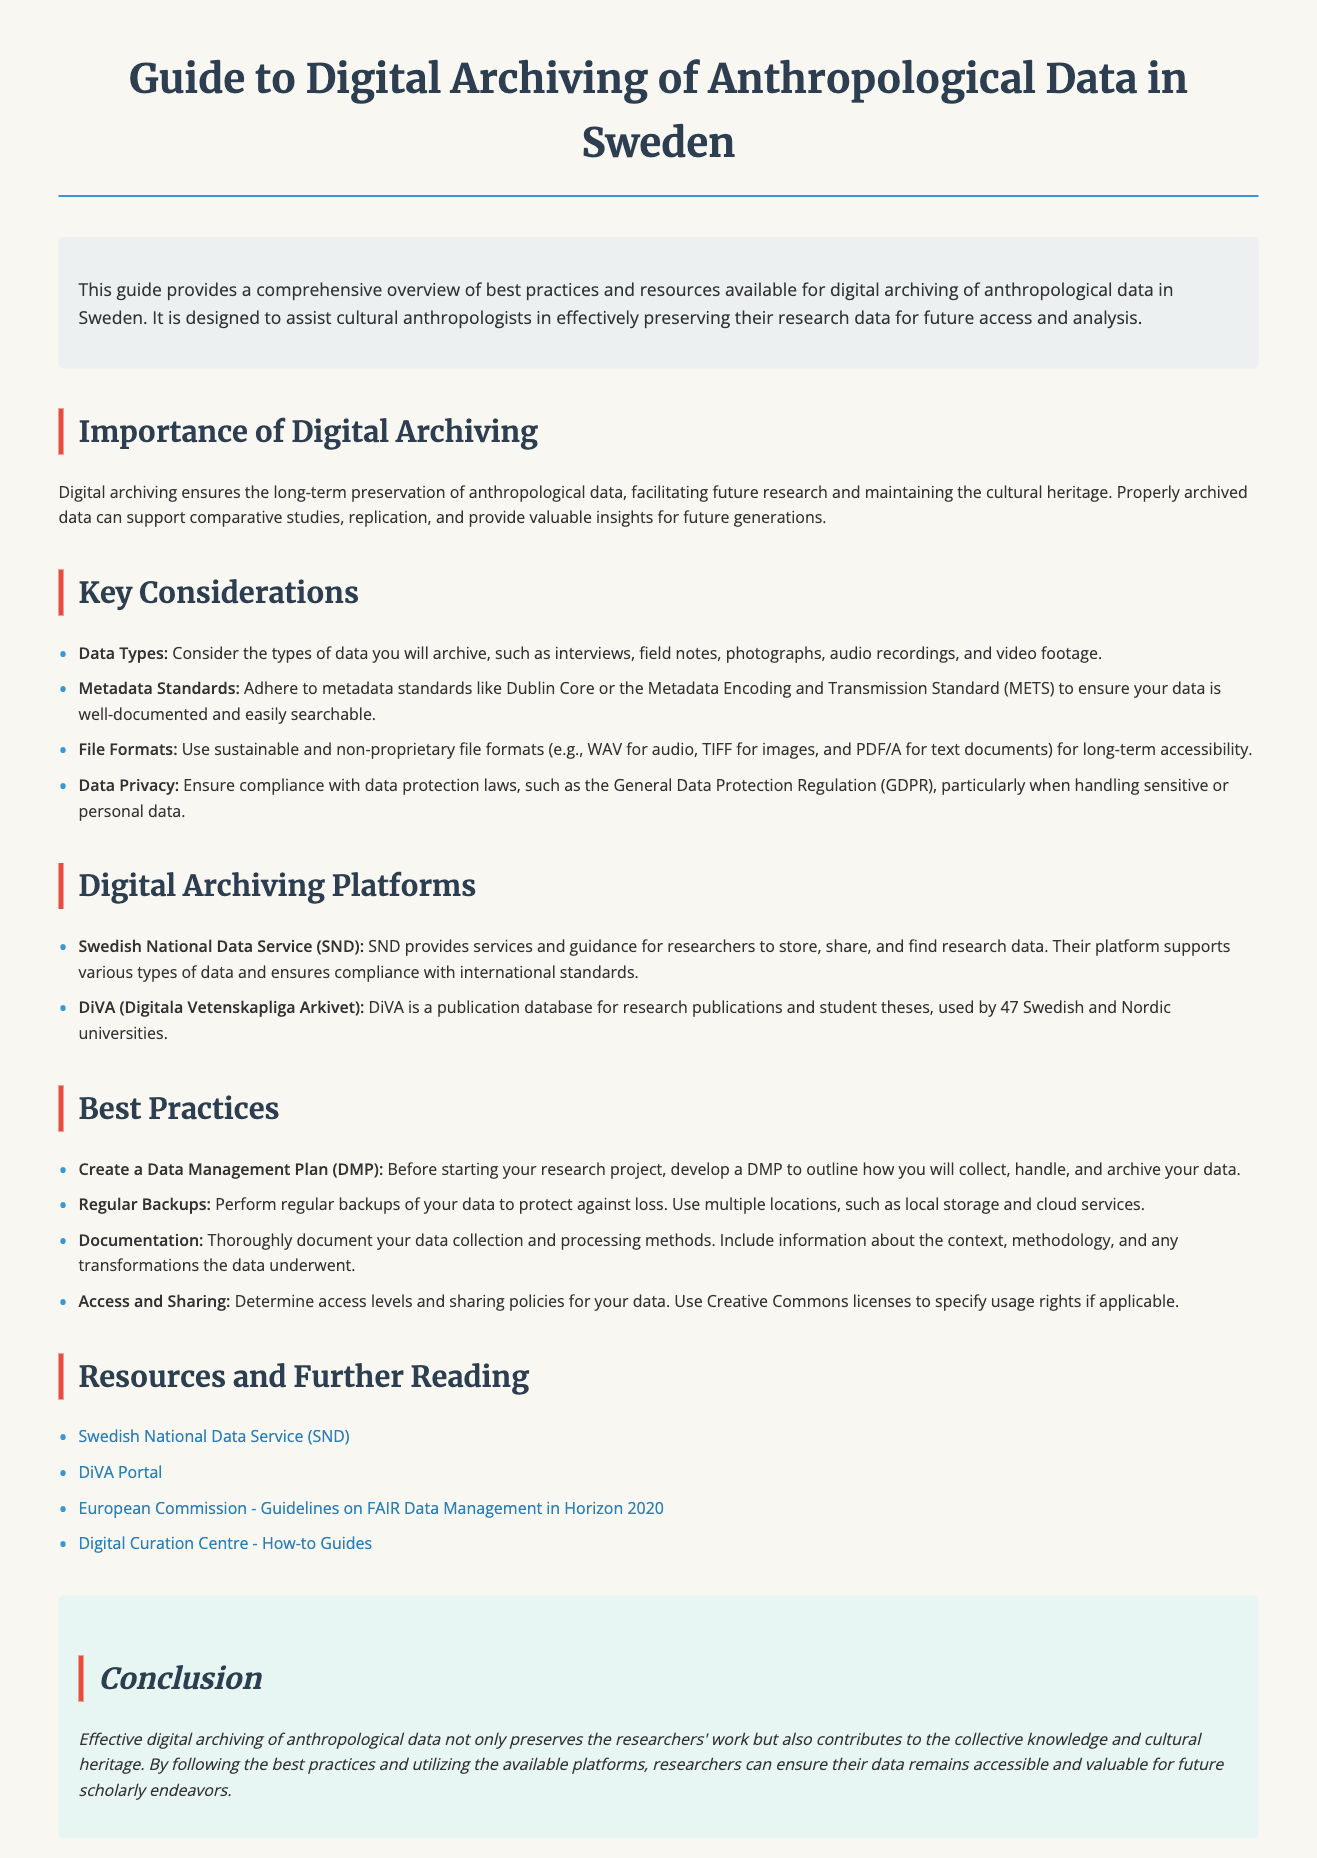What is the title of the document? The title of the document provides a clear identification of its content, which is "Guide to Digital Archiving of Anthropological Data in Sweden."
Answer: Guide to Digital Archiving of Anthropological Data in Sweden How many digital archiving platforms are mentioned? The document lists two specific platforms for digital archiving, providing options for cultural anthropologists.
Answer: 2 What standard should be adhered to for metadata? The document specifies that researchers should adhere to certain metadata standards to ensure proper documentation of their data.
Answer: Dublin Core What type of plan should researchers create before starting a project? The guide suggests creating a specific type of plan that outlines how data will be managed throughout the research process.
Answer: Data Management Plan (DMP) Which organization provides services for researchers to store and share data? The document mentions a specific service provider that assists researchers with data storage and sharing, enhancing data accessibility.
Answer: Swedish National Data Service (SND) What is a recommended file format for audio recordings? The document explicitly advises on the use of sustainable file formats for different types of data, including audio.
Answer: WAV What should researchers perform regularly to protect their data? The guide emphasizes the importance of a particular action that helps safeguard data from potential loss.
Answer: Regular Backups What is a benefit of properly archived data? The document highlights a specific advantage of having data securely archived, which contributes to future scholarly work.
Answer: Comparative studies 